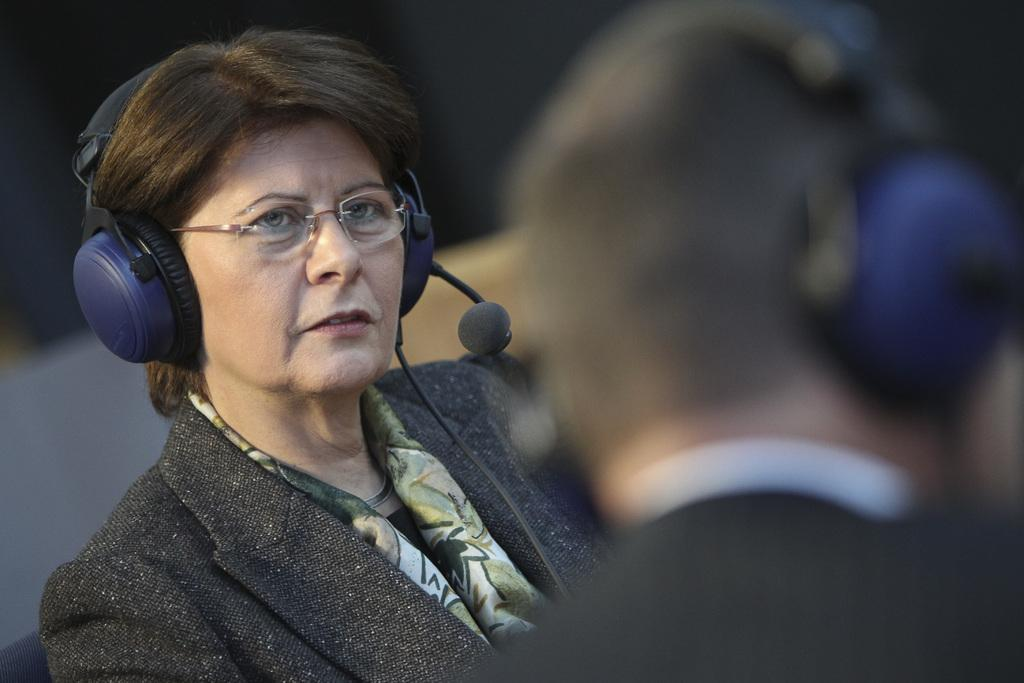What is the main subject of the image? There is a person in the image. What is the person wearing in the image? The person is wearing a microphone. What type of station is the person operating in the image? There is no indication of a station in the image; it only features a person wearing a microphone. 